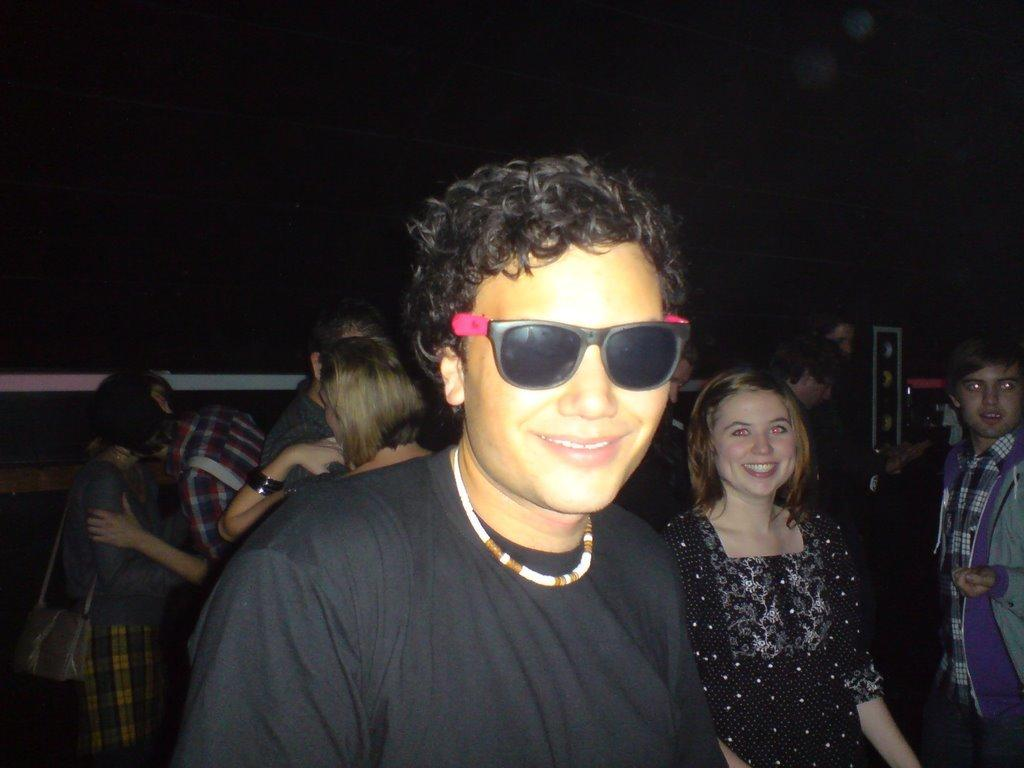What is the man in the image wearing? The man in the image is wearing sunglasses. Where is the woman located in the image? The woman is on the right side of the image. Can you describe the background of the image? There are people standing in the background of the image. How many leaves can be seen falling in the image? There are no leaves visible in the image. What action is the man taking to stop the woman from walking? There is no indication in the image that the man is trying to stop the woman from walking or that any such action is taking place. 